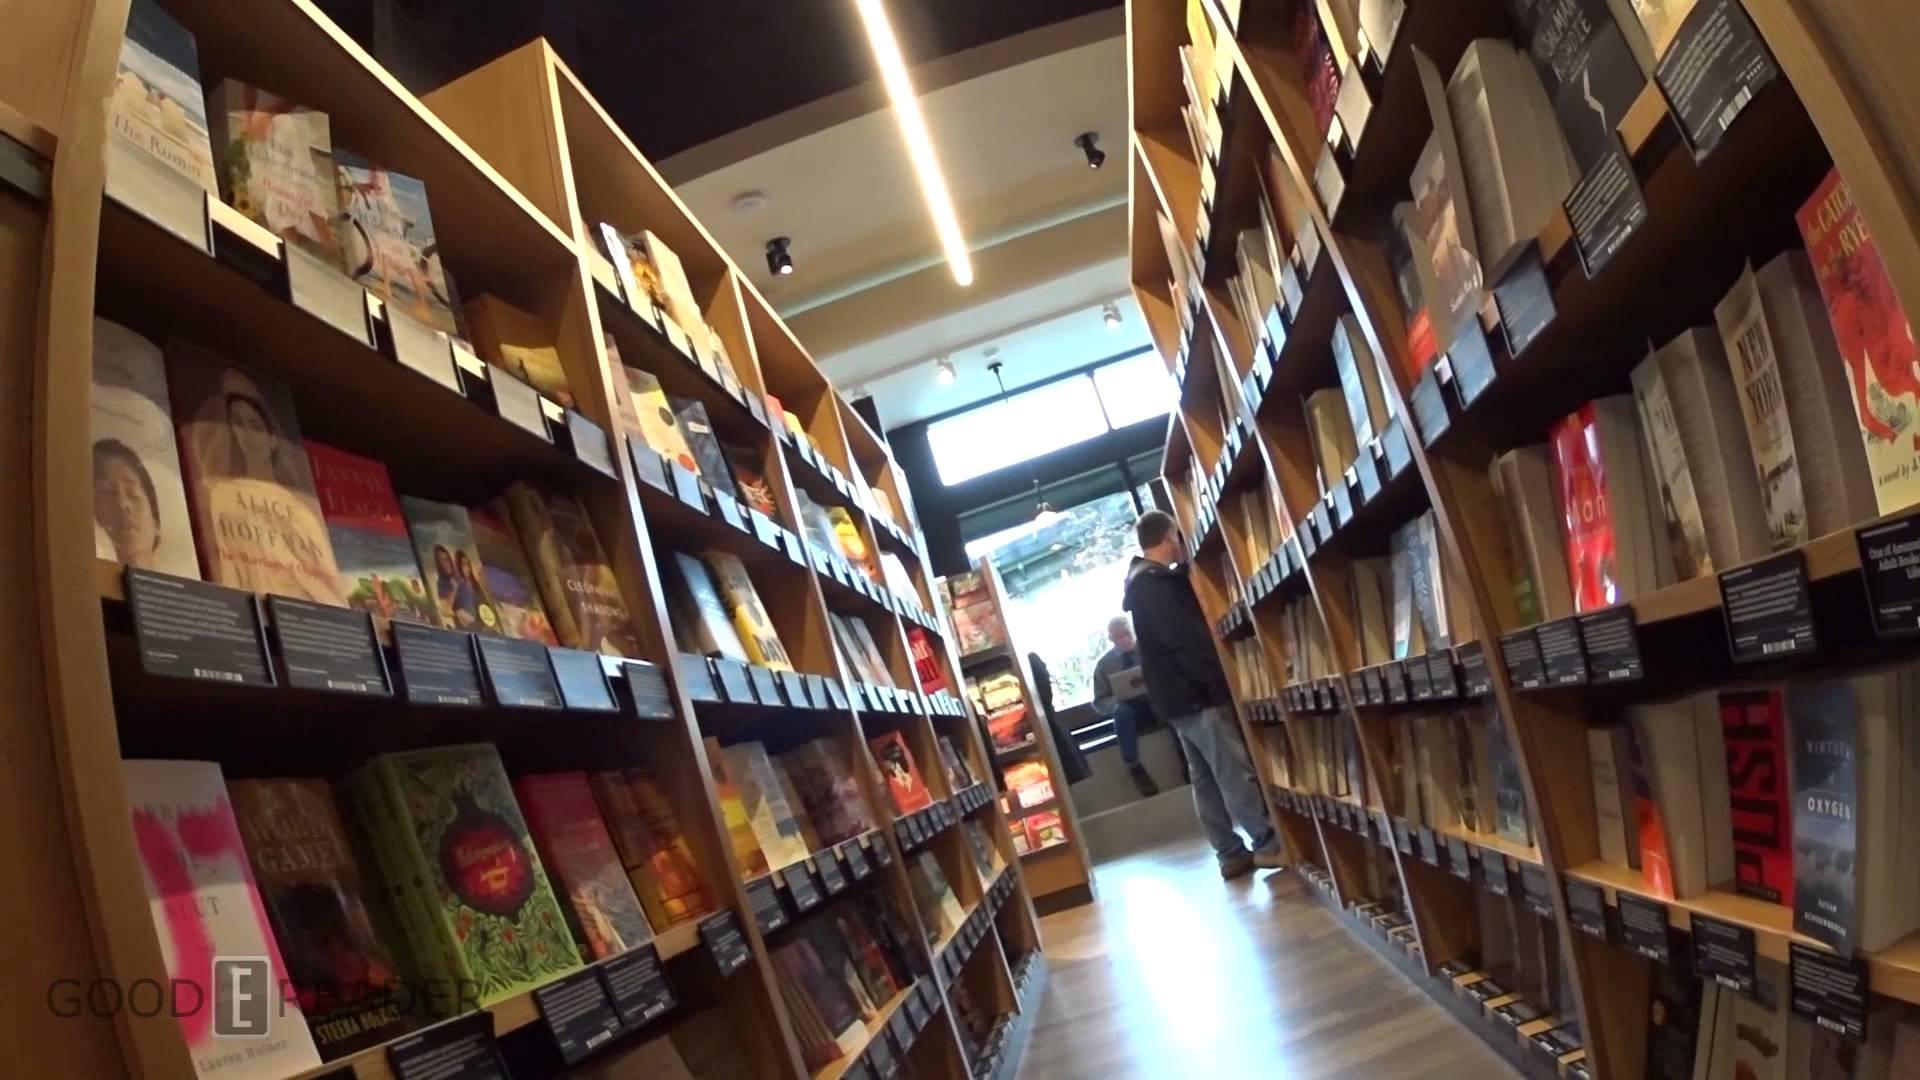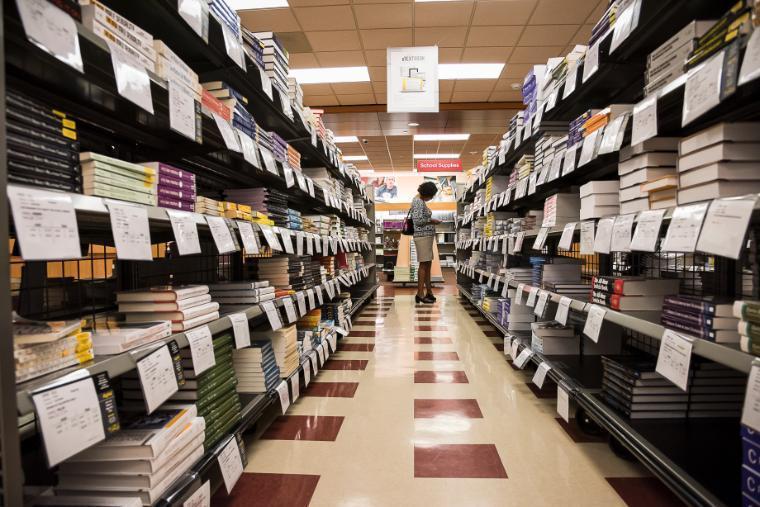The first image is the image on the left, the second image is the image on the right. Given the left and right images, does the statement "The left and right images show someone standing at the end of an aisle of books, but not in front of a table display." hold true? Answer yes or no. Yes. The first image is the image on the left, the second image is the image on the right. Assess this claim about the two images: "People are walking through the aisles of books in each of the images.". Correct or not? Answer yes or no. Yes. 